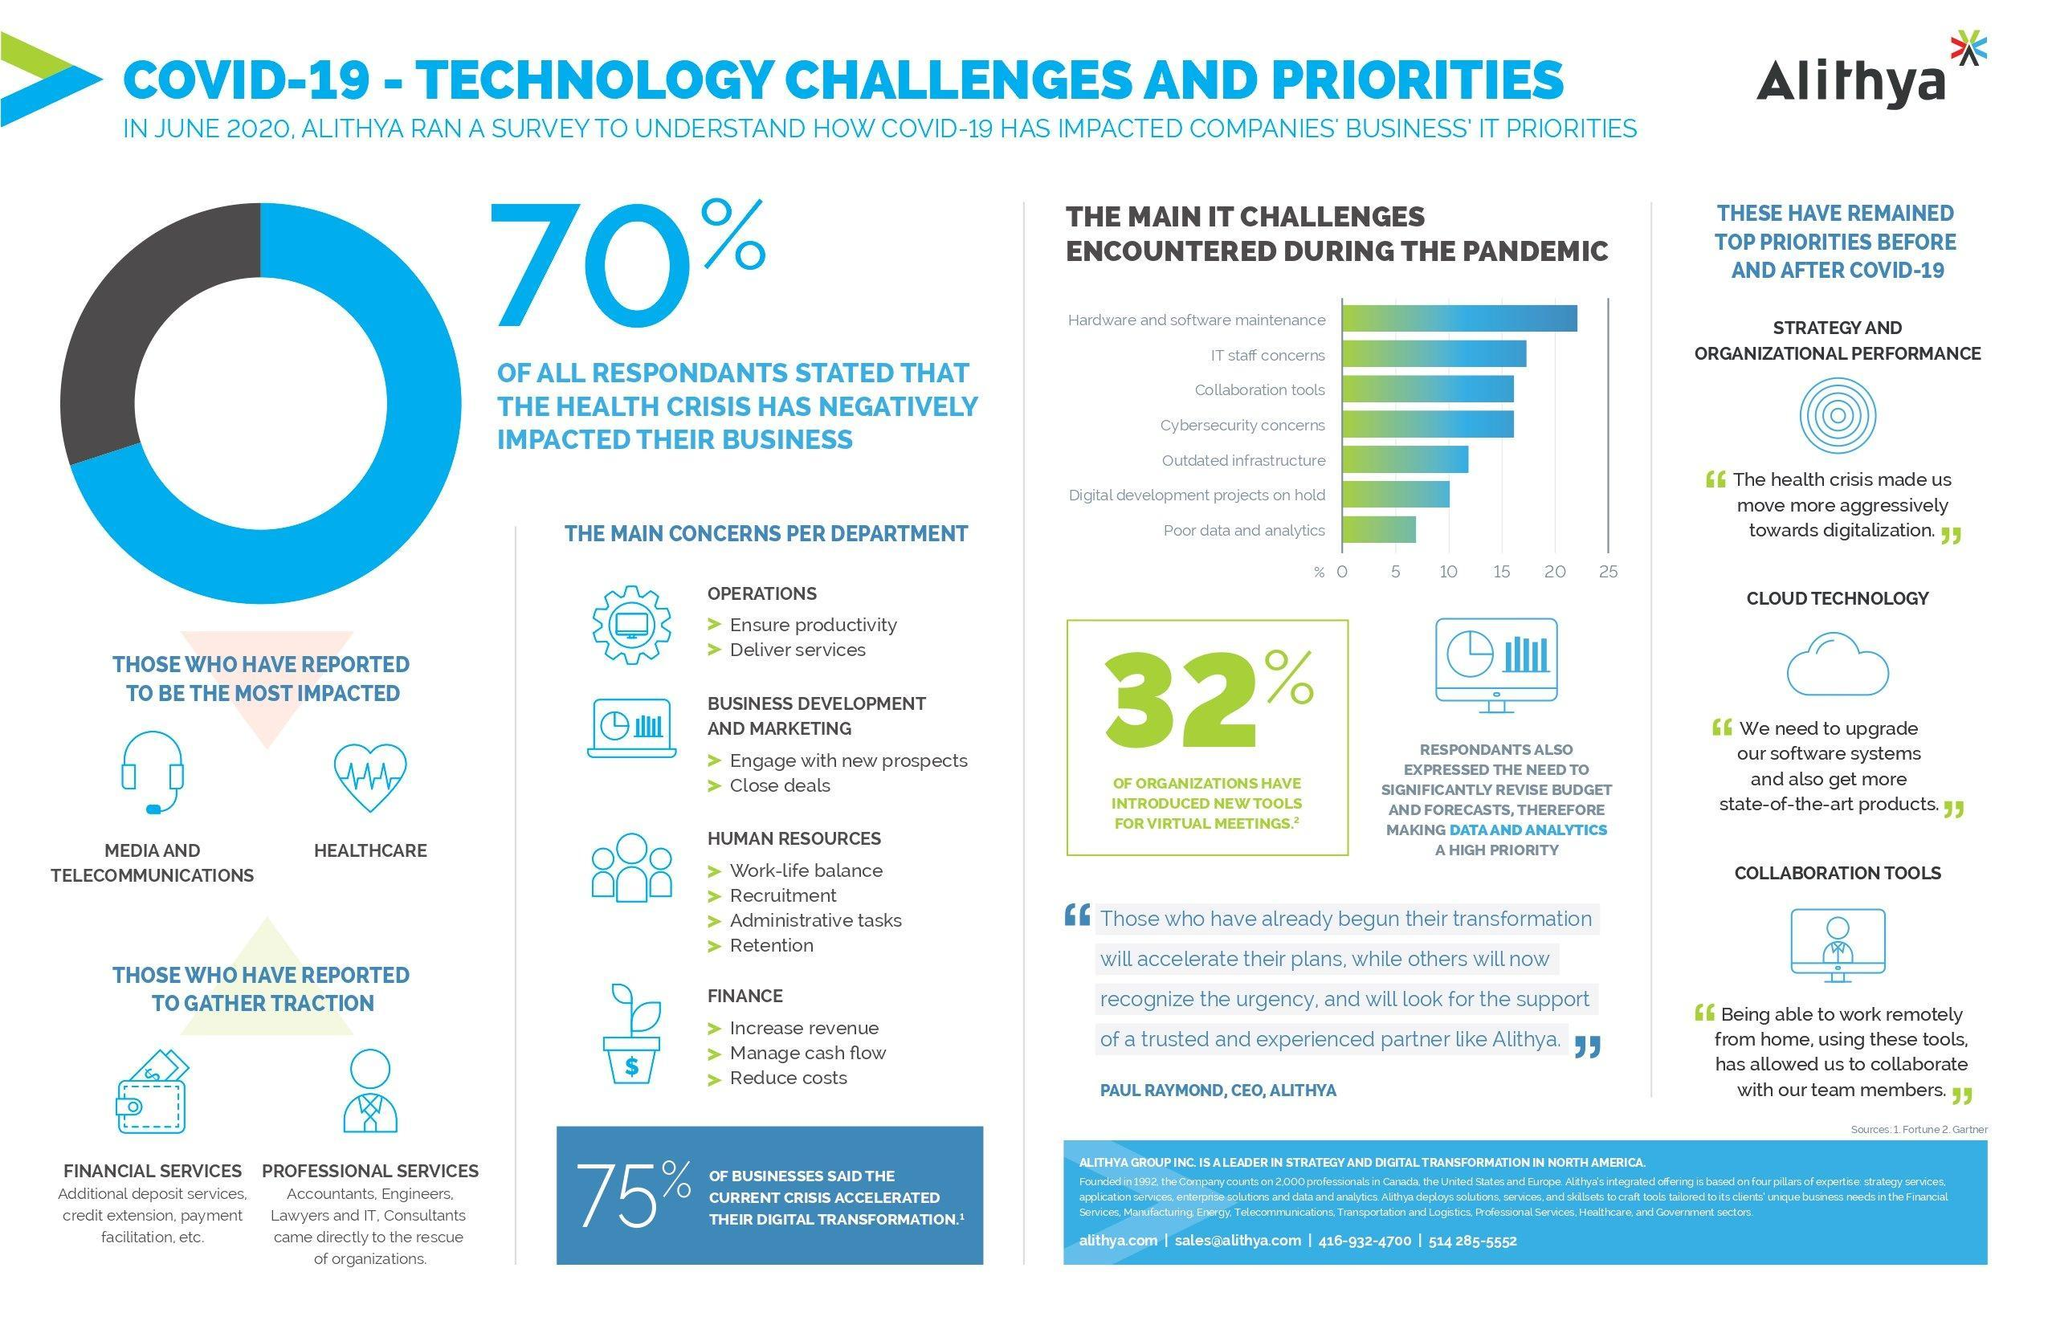What percent of respondents was not impacted negatively by the health crisis?
Answer the question with a short phrase. 30% Which IT challenge encountered during the pandemic crossed 20% as per the bar chart? Hardware and software maintenance 